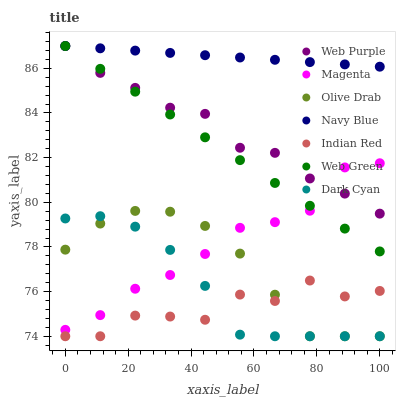Does Indian Red have the minimum area under the curve?
Answer yes or no. Yes. Does Navy Blue have the maximum area under the curve?
Answer yes or no. Yes. Does Web Green have the minimum area under the curve?
Answer yes or no. No. Does Web Green have the maximum area under the curve?
Answer yes or no. No. Is Web Green the smoothest?
Answer yes or no. Yes. Is Indian Red the roughest?
Answer yes or no. Yes. Is Web Purple the smoothest?
Answer yes or no. No. Is Web Purple the roughest?
Answer yes or no. No. Does Indian Red have the lowest value?
Answer yes or no. Yes. Does Web Green have the lowest value?
Answer yes or no. No. Does Web Purple have the highest value?
Answer yes or no. Yes. Does Indian Red have the highest value?
Answer yes or no. No. Is Indian Red less than Web Purple?
Answer yes or no. Yes. Is Navy Blue greater than Dark Cyan?
Answer yes or no. Yes. Does Indian Red intersect Dark Cyan?
Answer yes or no. Yes. Is Indian Red less than Dark Cyan?
Answer yes or no. No. Is Indian Red greater than Dark Cyan?
Answer yes or no. No. Does Indian Red intersect Web Purple?
Answer yes or no. No. 